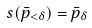<formula> <loc_0><loc_0><loc_500><loc_500>s ( \bar { p } _ { < \delta } ) = \bar { p } _ { \delta }</formula> 